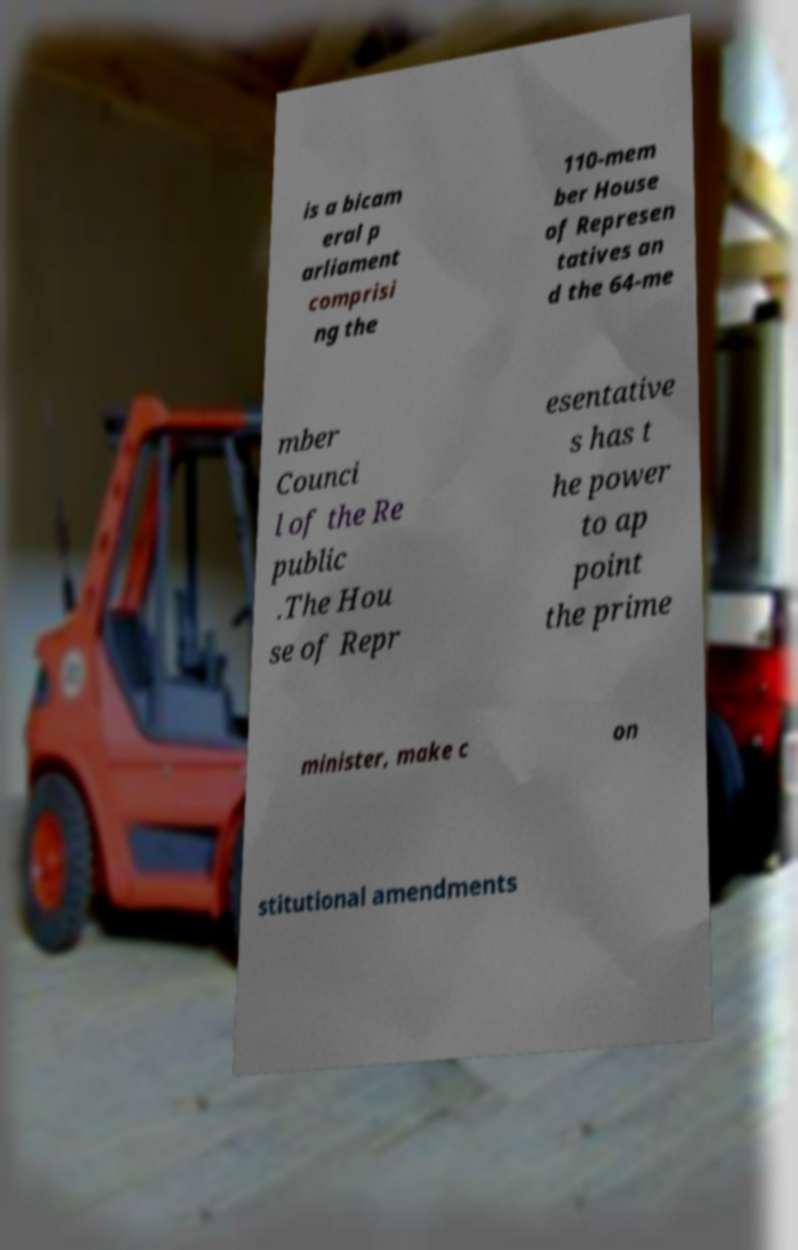There's text embedded in this image that I need extracted. Can you transcribe it verbatim? is a bicam eral p arliament comprisi ng the 110-mem ber House of Represen tatives an d the 64-me mber Counci l of the Re public .The Hou se of Repr esentative s has t he power to ap point the prime minister, make c on stitutional amendments 